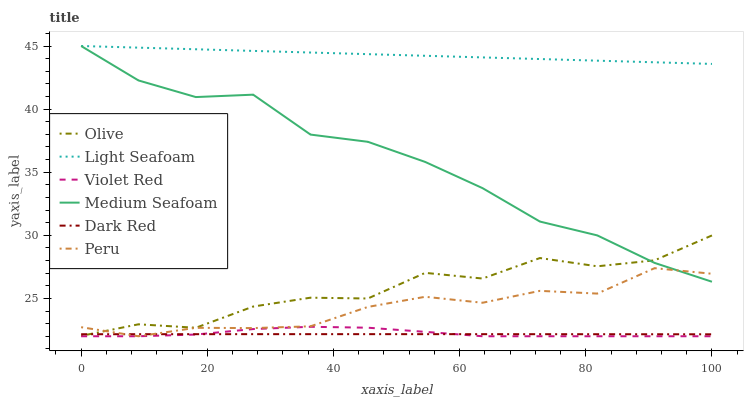Does Dark Red have the minimum area under the curve?
Answer yes or no. Yes. Does Light Seafoam have the maximum area under the curve?
Answer yes or no. Yes. Does Peru have the minimum area under the curve?
Answer yes or no. No. Does Peru have the maximum area under the curve?
Answer yes or no. No. Is Light Seafoam the smoothest?
Answer yes or no. Yes. Is Olive the roughest?
Answer yes or no. Yes. Is Dark Red the smoothest?
Answer yes or no. No. Is Dark Red the roughest?
Answer yes or no. No. Does Violet Red have the lowest value?
Answer yes or no. Yes. Does Dark Red have the lowest value?
Answer yes or no. No. Does Medium Seafoam have the highest value?
Answer yes or no. Yes. Does Peru have the highest value?
Answer yes or no. No. Is Dark Red less than Medium Seafoam?
Answer yes or no. Yes. Is Medium Seafoam greater than Violet Red?
Answer yes or no. Yes. Does Light Seafoam intersect Medium Seafoam?
Answer yes or no. Yes. Is Light Seafoam less than Medium Seafoam?
Answer yes or no. No. Is Light Seafoam greater than Medium Seafoam?
Answer yes or no. No. Does Dark Red intersect Medium Seafoam?
Answer yes or no. No. 